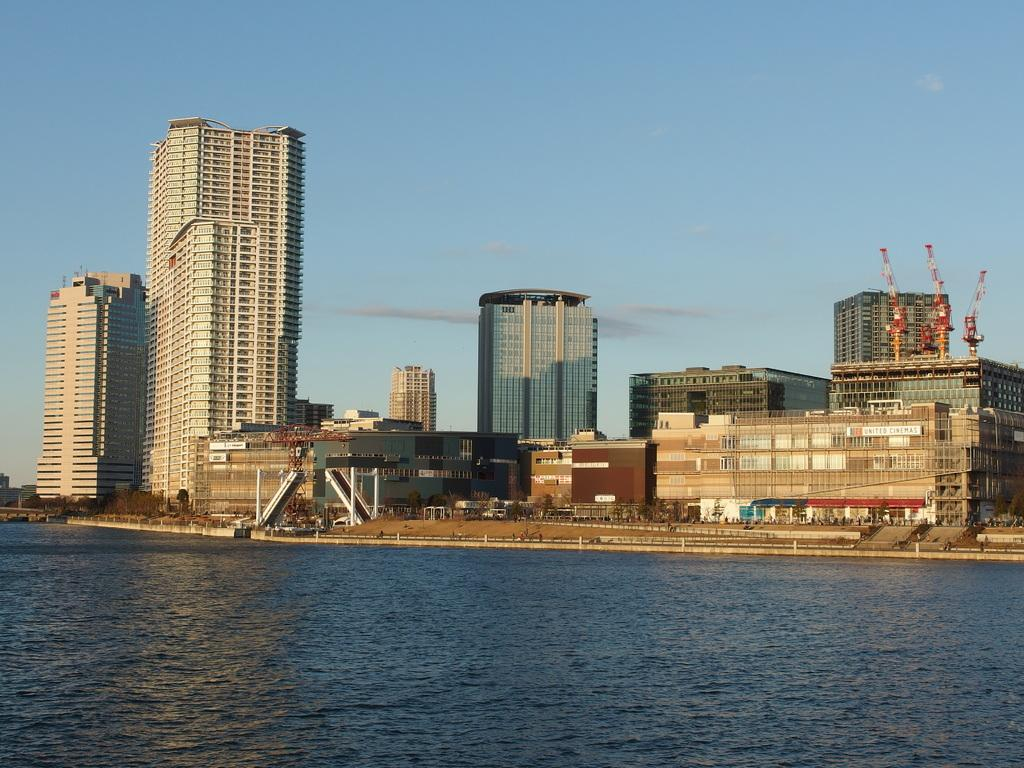What is in the foreground of the image? There is water in the foreground of the image. What can be seen in the background of the image? There are buildings, trees, and cranes on the buildings in the background of the image. What is visible in the sky in the background of the image? The sky is visible in the background of the image, and there is a cloud in the sky. What type of meat is being served by the grandmother in the image? There is no meat or grandmother present in the image. What advice is being given by the person in the image? There is no person or advice being given in the image. 